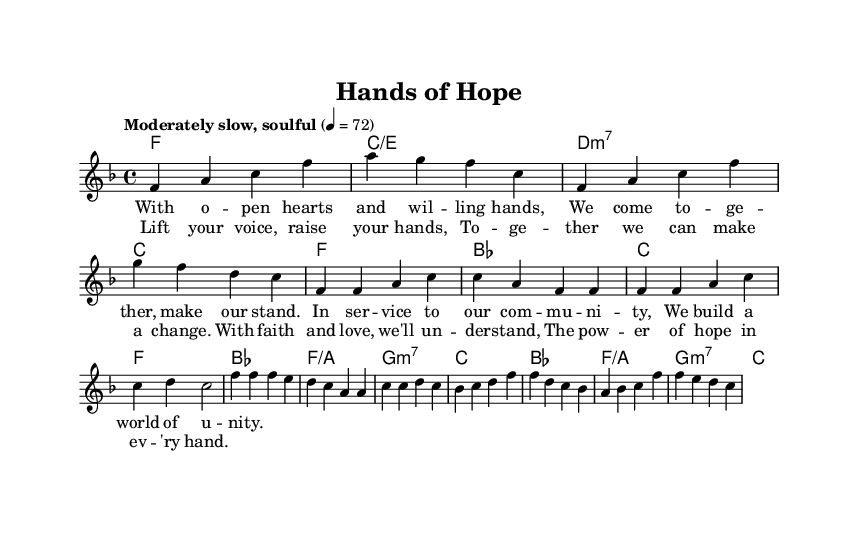What is the key signature of this music? The key signature indicated at the beginning of the score shows one flat, which corresponds to F major.
Answer: F major What is the time signature of the piece? The time signature is at the beginning of the score, displaying a 4 over 4, indicating four beats per measure.
Answer: 4/4 What is the tempo marking for this piece? The tempo marking indicates "Moderately slow, soulful," which provides the feel of how the piece should be played.
Answer: Moderately slow, soulful How many measures are present in the verse section? Counting the measures within the verse section, there are a total of 4 measures indicated after the introduction.
Answer: 4 measures What chord is played on the first measure of the chorus? Looking at the chord symbols, the first measure of the chorus shows a B flat major chord.
Answer: B flat major Which section contains lyrics about community service? The first set of lyrics under the verse is about coming together in service for the community.
Answer: Verse What musical genre does this piece represent? The combination of soulful melodies and themes of community service indicates it is a fusion of Rhythm and Blues with gospel elements.
Answer: Rhythm and Blues 